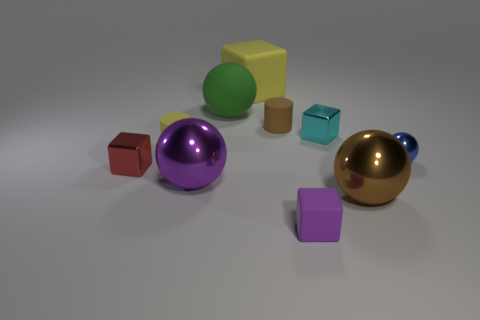What material is the cylinder that is the same color as the large block?
Keep it short and to the point. Rubber. What number of cylinders are brown rubber objects or yellow things?
Give a very brief answer. 2. Is the material of the purple block the same as the large yellow thing?
Offer a very short reply. Yes. What number of other things are the same color as the small sphere?
Offer a terse response. 0. There is a small thing in front of the purple metallic thing; what shape is it?
Offer a terse response. Cube. How many things are either small purple cubes or big things?
Your response must be concise. 5. Do the brown rubber cylinder and the yellow matte thing to the right of the yellow cylinder have the same size?
Your answer should be very brief. No. What number of other things are there of the same material as the yellow cube
Provide a short and direct response. 4. What number of things are either small shiny blocks on the left side of the small brown matte cylinder or tiny things that are on the right side of the tiny brown thing?
Provide a short and direct response. 4. What material is the brown thing that is the same shape as the green object?
Provide a succinct answer. Metal. 